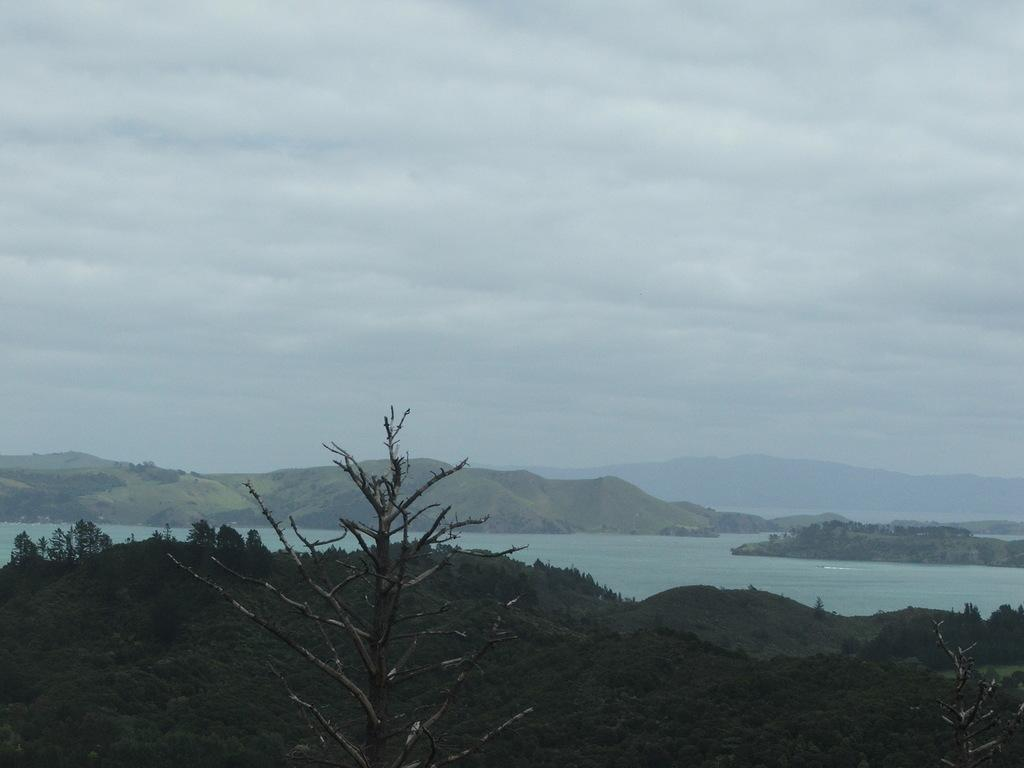What type of vegetation is present at the bottom of the image? There are trees at the bottom of the image. What natural element is in the middle of the image? There is water in the middle of the image. What is visible at the top of the image? There is sky at the top of the image. What type of geographical feature can be seen in the middle of the image? There are mountains in the middle of the image. How many women are participating in the competition in the image? There are no women or competition present in the image. What type of seed is growing at the bottom of the image? There is no seed present in the image; it features trees at the bottom. 